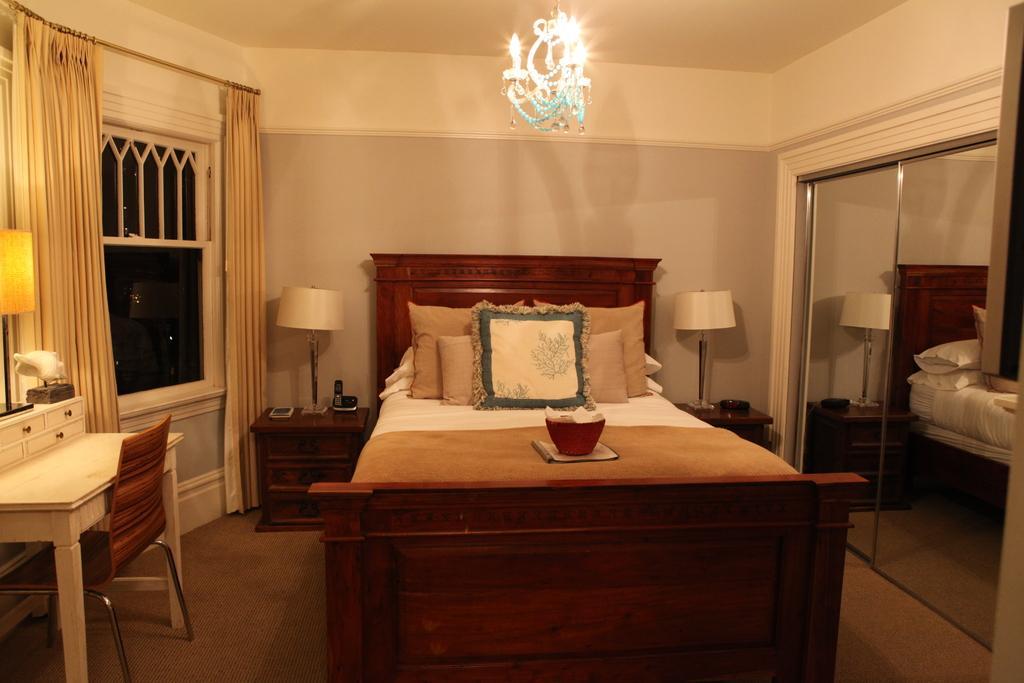Could you give a brief overview of what you see in this image? This image is clicked in a room. There is mirror on the right side and lamps. There is a bed in the middle. There is light on the top. There is a window on the left side and curtains too. There is a table, chair and the lamp on the left side. 